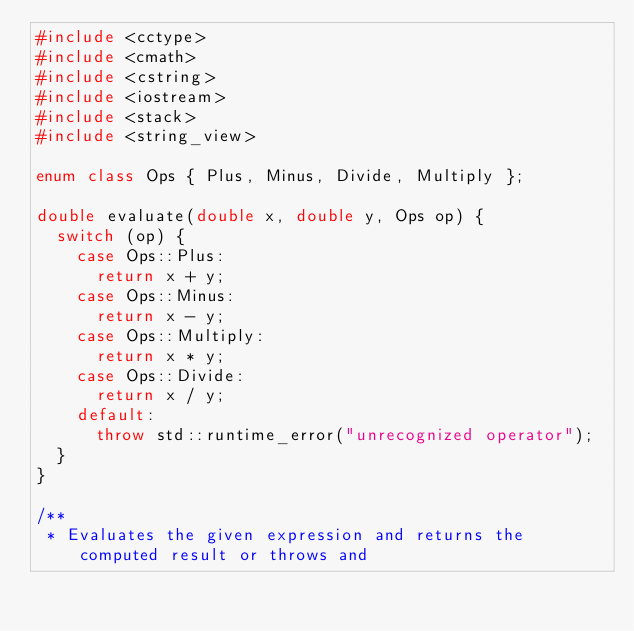Convert code to text. <code><loc_0><loc_0><loc_500><loc_500><_C++_>#include <cctype>
#include <cmath>
#include <cstring>
#include <iostream>
#include <stack>
#include <string_view>

enum class Ops { Plus, Minus, Divide, Multiply };

double evaluate(double x, double y, Ops op) {
  switch (op) {
    case Ops::Plus:
      return x + y;
    case Ops::Minus:
      return x - y;
    case Ops::Multiply:
      return x * y;
    case Ops::Divide:
      return x / y;
    default:
      throw std::runtime_error("unrecognized operator");
  }
}

/**
 * Evaluates the given expression and returns the computed result or throws and</code> 